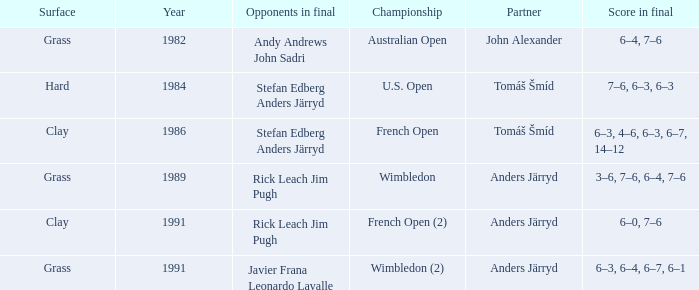What was the surface when he played with John Alexander?  Grass. 